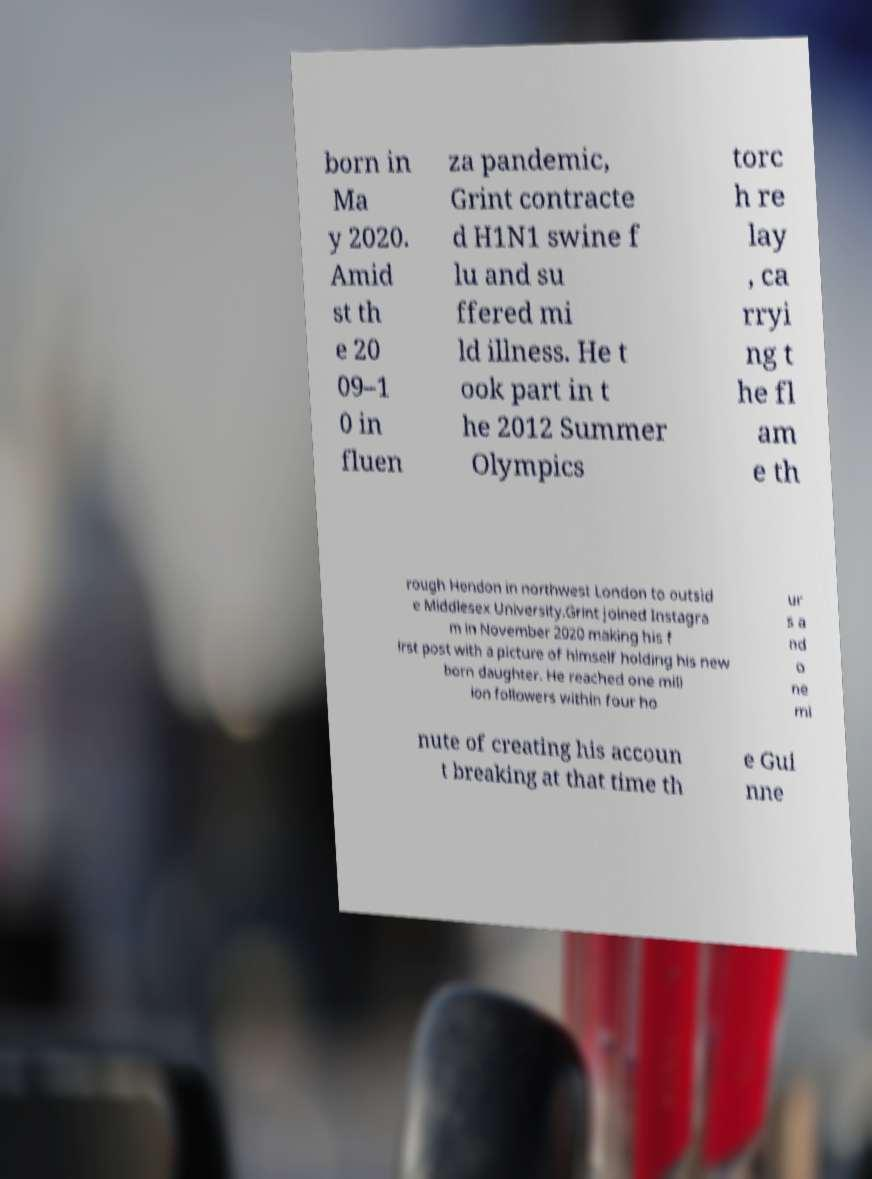Could you extract and type out the text from this image? born in Ma y 2020. Amid st th e 20 09–1 0 in fluen za pandemic, Grint contracte d H1N1 swine f lu and su ffered mi ld illness. He t ook part in t he 2012 Summer Olympics torc h re lay , ca rryi ng t he fl am e th rough Hendon in northwest London to outsid e Middlesex University.Grint joined Instagra m in November 2020 making his f irst post with a picture of himself holding his new born daughter. He reached one mill ion followers within four ho ur s a nd o ne mi nute of creating his accoun t breaking at that time th e Gui nne 